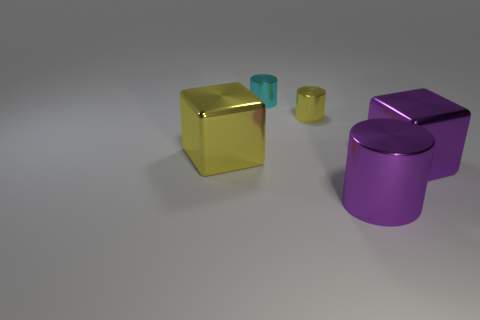There is a thing that is the same color as the large cylinder; what size is it?
Keep it short and to the point. Large. Do the metallic cube that is left of the large cylinder and the big cube that is right of the tiny yellow thing have the same color?
Your answer should be very brief. No. Do the purple object that is behind the large purple metal cylinder and the block that is on the left side of the big cylinder have the same material?
Offer a very short reply. Yes. The object that is both to the left of the small yellow object and in front of the cyan object has what shape?
Offer a terse response. Cube. The large thing that is on the left side of the large purple block and in front of the large yellow metallic thing is made of what material?
Provide a short and direct response. Metal. There is a cyan thing that is made of the same material as the big purple block; what is its shape?
Provide a short and direct response. Cylinder. How many yellow things have the same size as the cyan shiny thing?
Offer a terse response. 1. Is the number of small cyan shiny things that are to the right of the tiny yellow thing the same as the number of large blocks that are to the left of the large yellow shiny thing?
Give a very brief answer. Yes. Are the large purple cube and the yellow cube made of the same material?
Provide a succinct answer. Yes. There is a cylinder that is in front of the yellow cube; is there a large yellow metallic cube on the right side of it?
Ensure brevity in your answer.  No. 